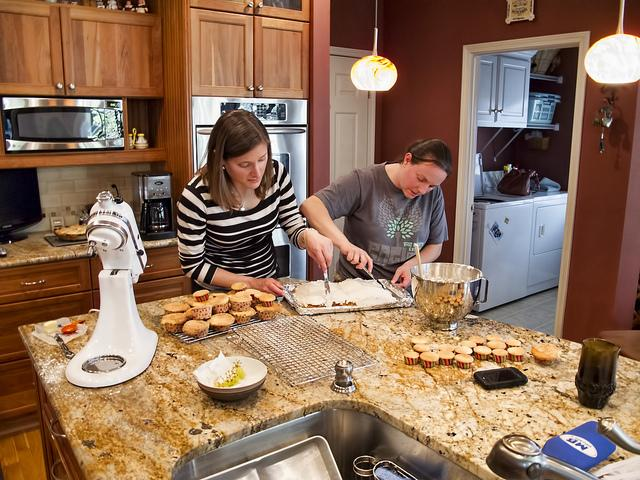What have these ladies been doing?

Choices:
A) drinking
B) baking
C) sleeping
D) watching tv baking 